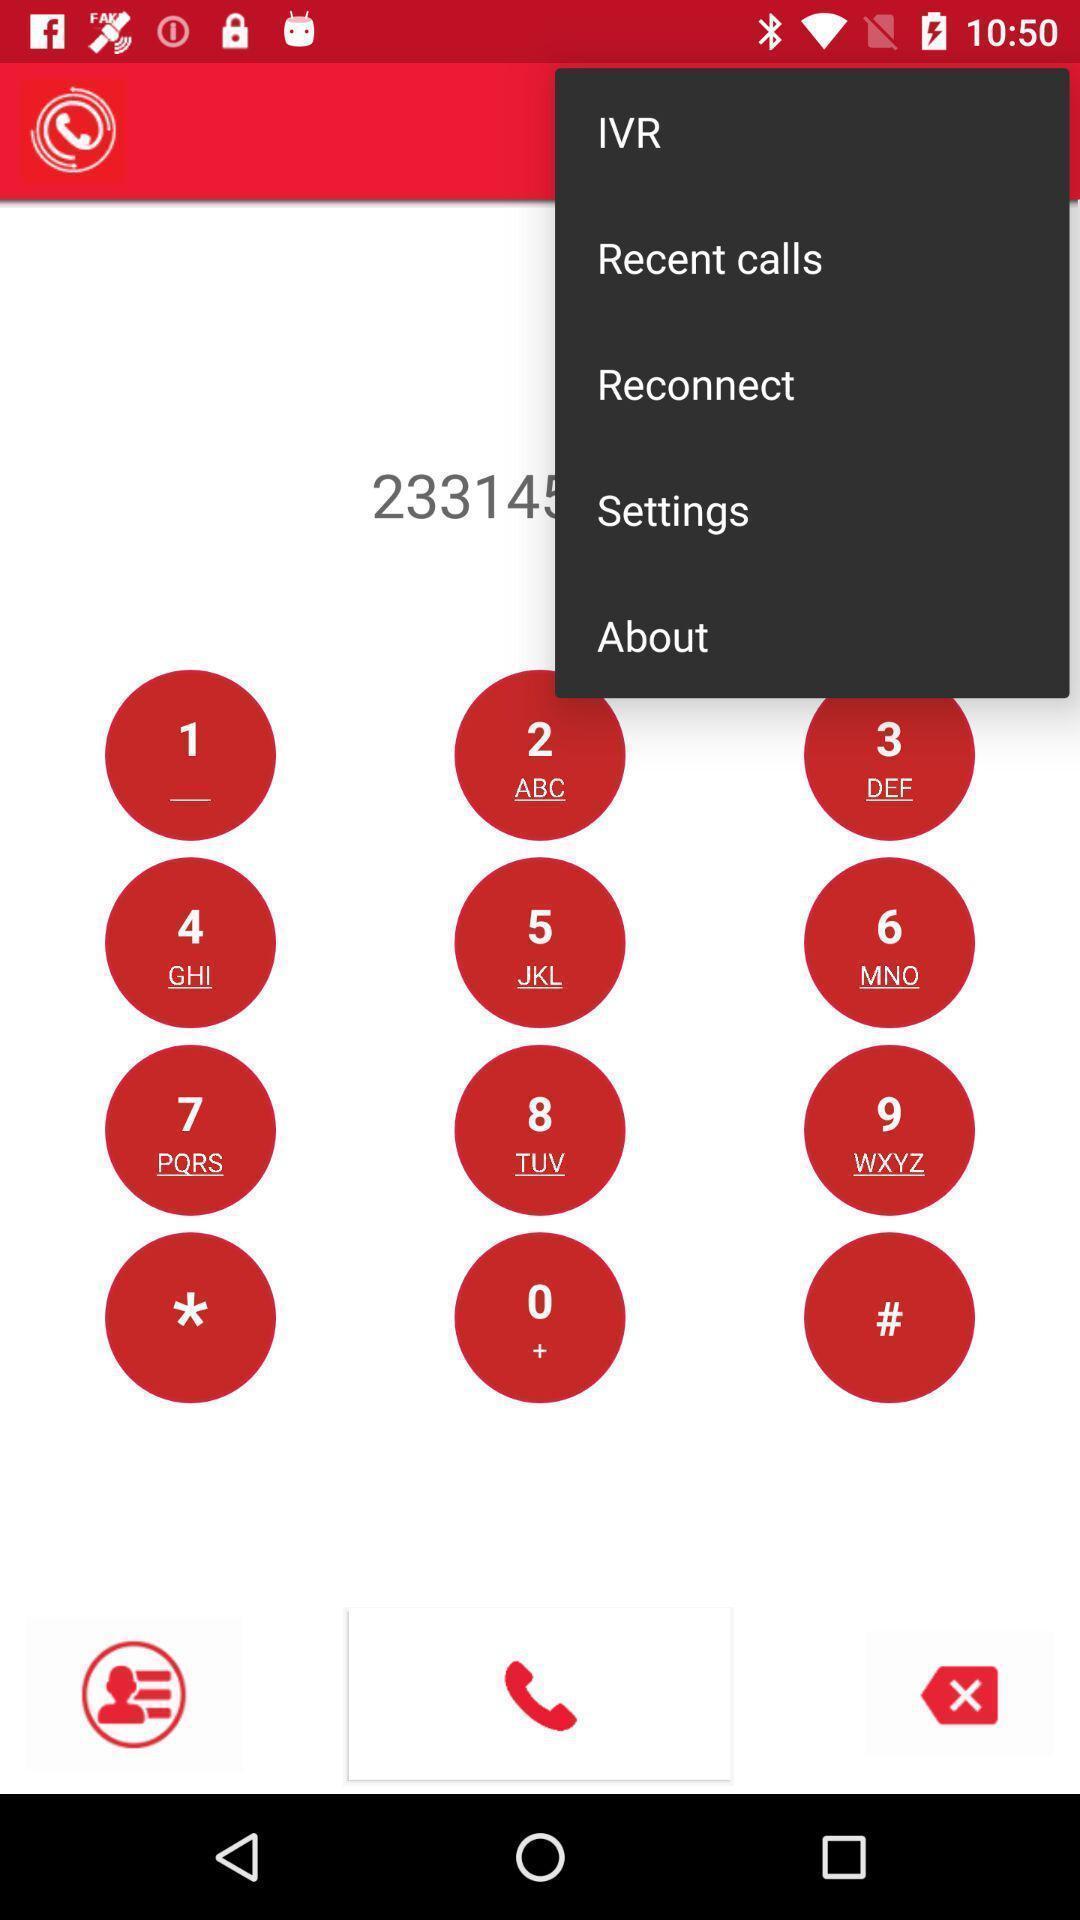Describe the content in this image. Pop up showing list of options. 